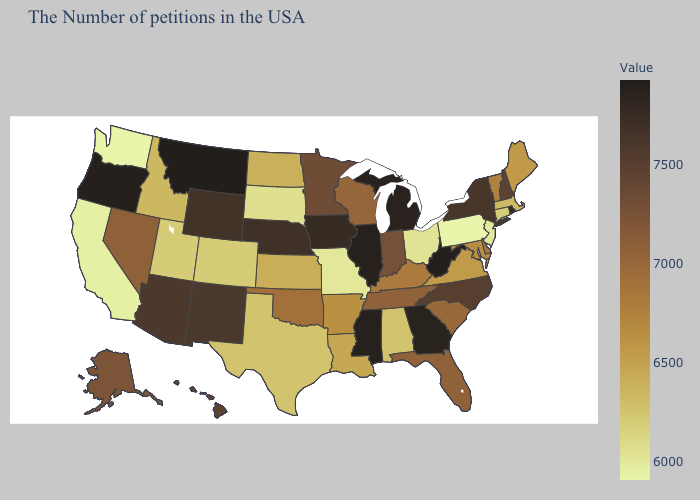Among the states that border Alabama , does Florida have the highest value?
Quick response, please. No. Among the states that border Tennessee , does Missouri have the lowest value?
Be succinct. Yes. Is the legend a continuous bar?
Keep it brief. Yes. Is the legend a continuous bar?
Be succinct. Yes. 